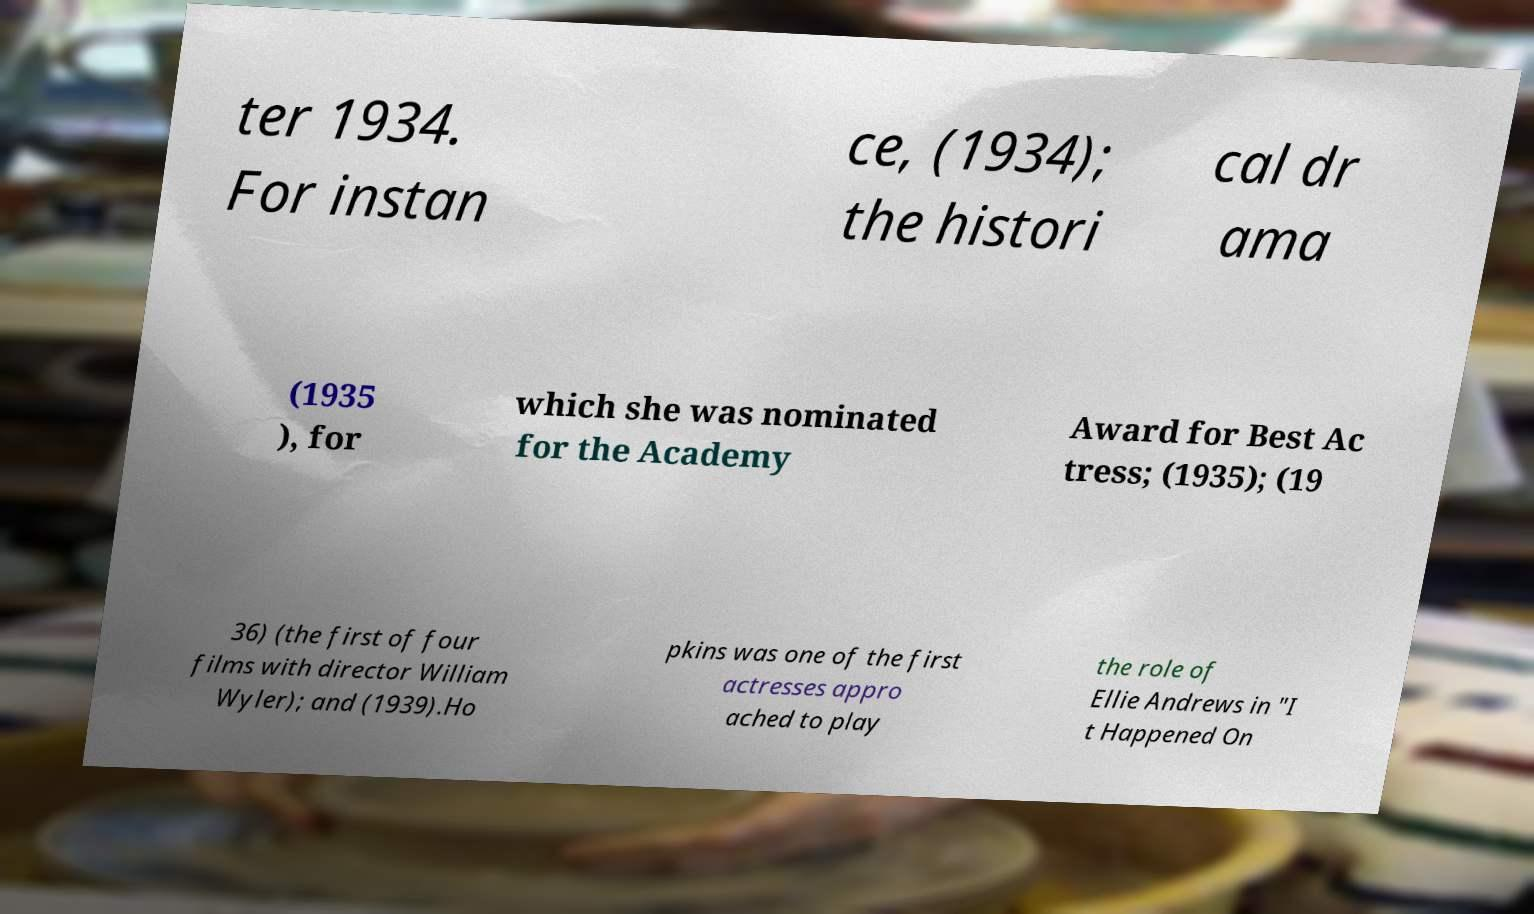Please identify and transcribe the text found in this image. ter 1934. For instan ce, (1934); the histori cal dr ama (1935 ), for which she was nominated for the Academy Award for Best Ac tress; (1935); (19 36) (the first of four films with director William Wyler); and (1939).Ho pkins was one of the first actresses appro ached to play the role of Ellie Andrews in "I t Happened On 